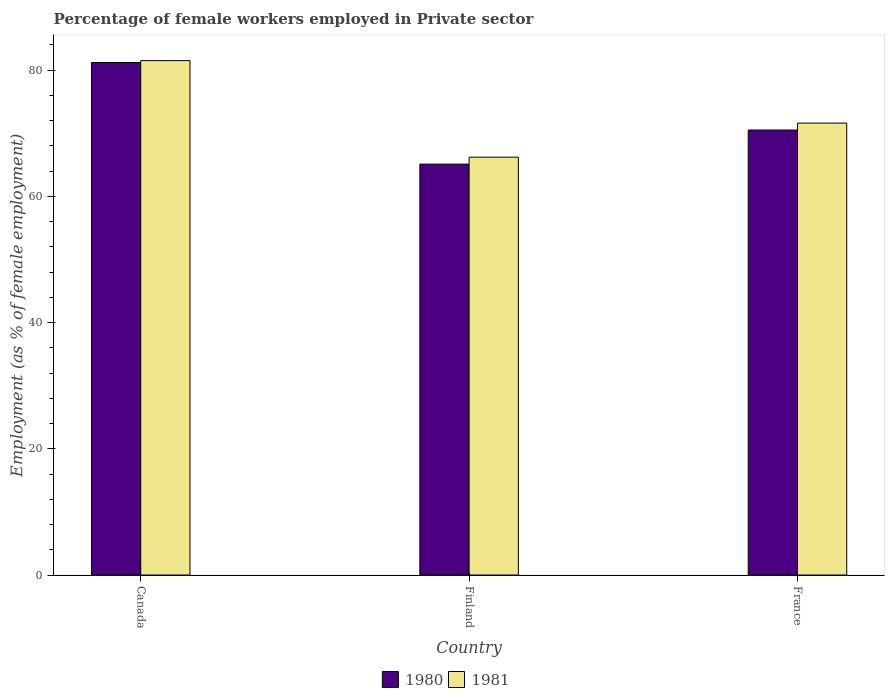Are the number of bars on each tick of the X-axis equal?
Ensure brevity in your answer.  Yes. How many bars are there on the 3rd tick from the right?
Provide a short and direct response. 2. What is the percentage of females employed in Private sector in 1981 in Finland?
Your response must be concise. 66.2. Across all countries, what is the maximum percentage of females employed in Private sector in 1981?
Provide a short and direct response. 81.5. Across all countries, what is the minimum percentage of females employed in Private sector in 1980?
Your answer should be very brief. 65.1. In which country was the percentage of females employed in Private sector in 1981 minimum?
Keep it short and to the point. Finland. What is the total percentage of females employed in Private sector in 1980 in the graph?
Ensure brevity in your answer.  216.8. What is the difference between the percentage of females employed in Private sector in 1980 in Canada and that in France?
Provide a short and direct response. 10.7. What is the difference between the percentage of females employed in Private sector in 1981 in France and the percentage of females employed in Private sector in 1980 in Canada?
Ensure brevity in your answer.  -9.6. What is the average percentage of females employed in Private sector in 1980 per country?
Provide a short and direct response. 72.27. What is the difference between the percentage of females employed in Private sector of/in 1981 and percentage of females employed in Private sector of/in 1980 in France?
Provide a succinct answer. 1.1. In how many countries, is the percentage of females employed in Private sector in 1980 greater than 12 %?
Provide a short and direct response. 3. What is the ratio of the percentage of females employed in Private sector in 1980 in Canada to that in France?
Your answer should be very brief. 1.15. Is the difference between the percentage of females employed in Private sector in 1981 in Finland and France greater than the difference between the percentage of females employed in Private sector in 1980 in Finland and France?
Ensure brevity in your answer.  Yes. What is the difference between the highest and the second highest percentage of females employed in Private sector in 1980?
Give a very brief answer. -16.1. What is the difference between the highest and the lowest percentage of females employed in Private sector in 1980?
Your response must be concise. 16.1. In how many countries, is the percentage of females employed in Private sector in 1980 greater than the average percentage of females employed in Private sector in 1980 taken over all countries?
Provide a succinct answer. 1. What does the 2nd bar from the left in France represents?
Your answer should be very brief. 1981. Are all the bars in the graph horizontal?
Your response must be concise. No. What is the difference between two consecutive major ticks on the Y-axis?
Provide a short and direct response. 20. Are the values on the major ticks of Y-axis written in scientific E-notation?
Your answer should be compact. No. Does the graph contain any zero values?
Offer a very short reply. No. Where does the legend appear in the graph?
Offer a terse response. Bottom center. How many legend labels are there?
Keep it short and to the point. 2. How are the legend labels stacked?
Your answer should be very brief. Horizontal. What is the title of the graph?
Your answer should be compact. Percentage of female workers employed in Private sector. What is the label or title of the Y-axis?
Make the answer very short. Employment (as % of female employment). What is the Employment (as % of female employment) in 1980 in Canada?
Your answer should be very brief. 81.2. What is the Employment (as % of female employment) of 1981 in Canada?
Keep it short and to the point. 81.5. What is the Employment (as % of female employment) of 1980 in Finland?
Ensure brevity in your answer.  65.1. What is the Employment (as % of female employment) of 1981 in Finland?
Your response must be concise. 66.2. What is the Employment (as % of female employment) in 1980 in France?
Offer a terse response. 70.5. What is the Employment (as % of female employment) of 1981 in France?
Your response must be concise. 71.6. Across all countries, what is the maximum Employment (as % of female employment) of 1980?
Your answer should be very brief. 81.2. Across all countries, what is the maximum Employment (as % of female employment) of 1981?
Offer a very short reply. 81.5. Across all countries, what is the minimum Employment (as % of female employment) in 1980?
Give a very brief answer. 65.1. Across all countries, what is the minimum Employment (as % of female employment) in 1981?
Provide a succinct answer. 66.2. What is the total Employment (as % of female employment) of 1980 in the graph?
Provide a short and direct response. 216.8. What is the total Employment (as % of female employment) of 1981 in the graph?
Your answer should be very brief. 219.3. What is the difference between the Employment (as % of female employment) in 1980 in Finland and that in France?
Offer a terse response. -5.4. What is the difference between the Employment (as % of female employment) in 1981 in Finland and that in France?
Keep it short and to the point. -5.4. What is the difference between the Employment (as % of female employment) in 1980 in Canada and the Employment (as % of female employment) in 1981 in France?
Offer a terse response. 9.6. What is the average Employment (as % of female employment) in 1980 per country?
Provide a succinct answer. 72.27. What is the average Employment (as % of female employment) of 1981 per country?
Offer a very short reply. 73.1. What is the difference between the Employment (as % of female employment) in 1980 and Employment (as % of female employment) in 1981 in Canada?
Provide a short and direct response. -0.3. What is the difference between the Employment (as % of female employment) of 1980 and Employment (as % of female employment) of 1981 in Finland?
Keep it short and to the point. -1.1. What is the ratio of the Employment (as % of female employment) in 1980 in Canada to that in Finland?
Provide a short and direct response. 1.25. What is the ratio of the Employment (as % of female employment) of 1981 in Canada to that in Finland?
Give a very brief answer. 1.23. What is the ratio of the Employment (as % of female employment) in 1980 in Canada to that in France?
Your response must be concise. 1.15. What is the ratio of the Employment (as % of female employment) in 1981 in Canada to that in France?
Your answer should be compact. 1.14. What is the ratio of the Employment (as % of female employment) in 1980 in Finland to that in France?
Keep it short and to the point. 0.92. What is the ratio of the Employment (as % of female employment) of 1981 in Finland to that in France?
Give a very brief answer. 0.92. What is the difference between the highest and the second highest Employment (as % of female employment) of 1980?
Ensure brevity in your answer.  10.7. What is the difference between the highest and the lowest Employment (as % of female employment) in 1980?
Offer a very short reply. 16.1. 